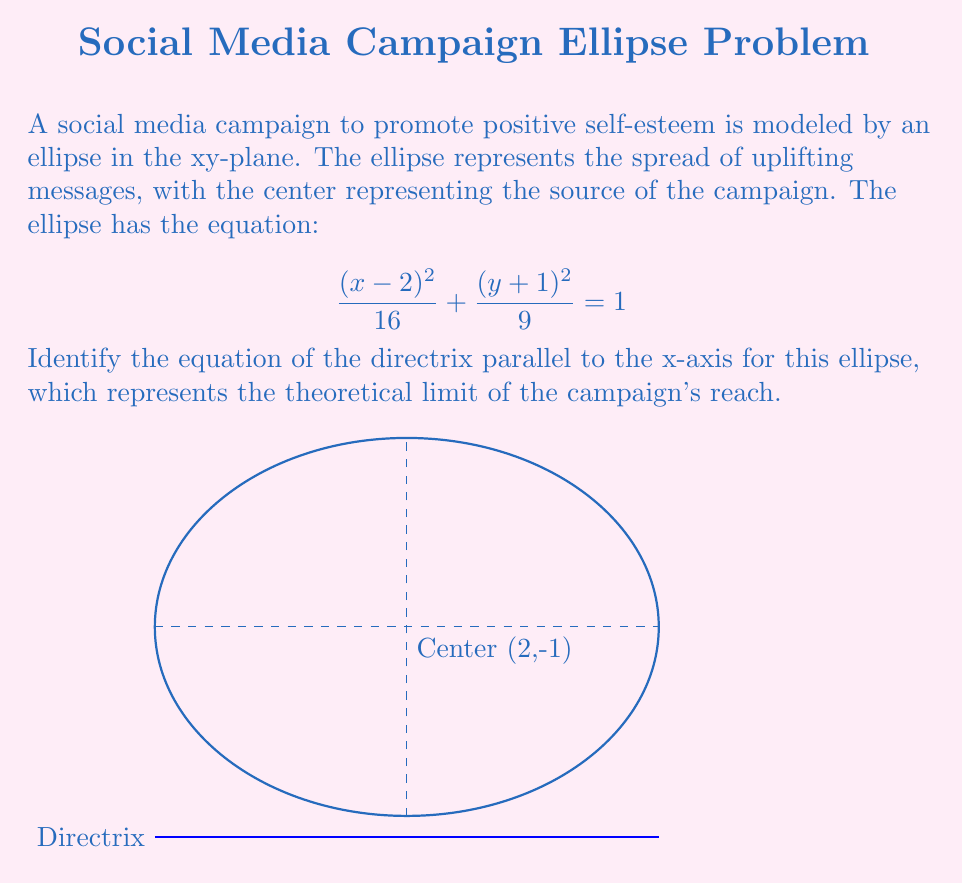Show me your answer to this math problem. Let's approach this step-by-step:

1) The general form of an ellipse equation is:
   $$\frac{(x-h)^2}{a^2} + \frac{(y-k)^2}{b^2} = 1$$
   where (h,k) is the center, and a and b are the lengths of the semi-major and semi-minor axes.

2) Comparing our equation to the general form:
   $$\frac{(x-2)^2}{16} + \frac{(y+1)^2}{9} = 1$$
   We can see that h = 2, k = -1, $a^2 = 16$, and $b^2 = 9$.

3) Therefore, a = 4 and b = 3.

4) The center of the ellipse is (2, -1).

5) To find the directrix, we need to calculate the eccentricity (e) of the ellipse:
   $$e = \sqrt{1 - \frac{b^2}{a^2}} = \sqrt{1 - \frac{9}{16}} = \frac{\sqrt{7}}{4}$$

6) The distance from the center to the directrix is given by $\frac{a}{e}$:
   $$\frac{a}{e} = \frac{4}{\frac{\sqrt{7}}{4}} = \frac{16}{\sqrt{7}}$$

7) Since we're asked for the directrix parallel to the x-axis, it will be above or below the center by this distance.

8) The y-coordinate of the directrix will be:
   $$y = k - \frac{a}{e} = -1 - \frac{16}{\sqrt{7}}$$

9) Therefore, the equation of the directrix is:
   $$y = -1 - \frac{16}{\sqrt{7}}$$
Answer: $y = -1 - \frac{16}{\sqrt{7}}$ 